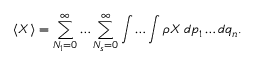<formula> <loc_0><loc_0><loc_500><loc_500>\langle X \rangle = \sum _ { N _ { 1 } = 0 } ^ { \infty } \dots \sum _ { N _ { s } = 0 } ^ { \infty } \int \dots \int \rho X \, d p _ { 1 } \dots d q _ { n } .</formula> 